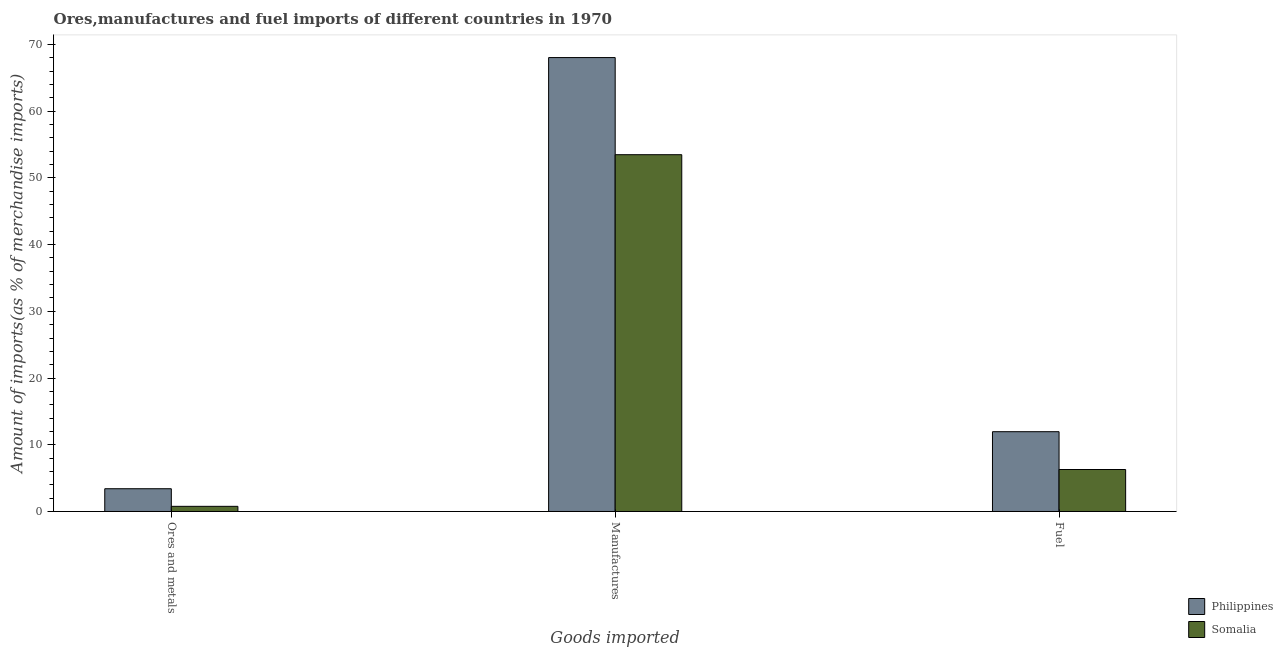How many bars are there on the 3rd tick from the left?
Offer a very short reply. 2. What is the label of the 1st group of bars from the left?
Your answer should be compact. Ores and metals. What is the percentage of manufactures imports in Philippines?
Make the answer very short. 68.03. Across all countries, what is the maximum percentage of manufactures imports?
Offer a very short reply. 68.03. Across all countries, what is the minimum percentage of fuel imports?
Your answer should be very brief. 6.29. In which country was the percentage of fuel imports minimum?
Offer a terse response. Somalia. What is the total percentage of manufactures imports in the graph?
Offer a terse response. 121.51. What is the difference between the percentage of manufactures imports in Somalia and that in Philippines?
Your answer should be very brief. -14.56. What is the difference between the percentage of fuel imports in Somalia and the percentage of manufactures imports in Philippines?
Make the answer very short. -61.74. What is the average percentage of fuel imports per country?
Make the answer very short. 9.12. What is the difference between the percentage of manufactures imports and percentage of ores and metals imports in Somalia?
Keep it short and to the point. 52.7. What is the ratio of the percentage of manufactures imports in Philippines to that in Somalia?
Ensure brevity in your answer.  1.27. Is the difference between the percentage of ores and metals imports in Somalia and Philippines greater than the difference between the percentage of fuel imports in Somalia and Philippines?
Keep it short and to the point. Yes. What is the difference between the highest and the second highest percentage of ores and metals imports?
Provide a short and direct response. 2.64. What is the difference between the highest and the lowest percentage of manufactures imports?
Offer a terse response. 14.56. In how many countries, is the percentage of ores and metals imports greater than the average percentage of ores and metals imports taken over all countries?
Keep it short and to the point. 1. Is the sum of the percentage of manufactures imports in Philippines and Somalia greater than the maximum percentage of ores and metals imports across all countries?
Ensure brevity in your answer.  Yes. What does the 1st bar from the right in Manufactures represents?
Your answer should be compact. Somalia. How many countries are there in the graph?
Ensure brevity in your answer.  2. Does the graph contain any zero values?
Offer a very short reply. No. Does the graph contain grids?
Make the answer very short. No. Where does the legend appear in the graph?
Make the answer very short. Bottom right. How are the legend labels stacked?
Make the answer very short. Vertical. What is the title of the graph?
Ensure brevity in your answer.  Ores,manufactures and fuel imports of different countries in 1970. What is the label or title of the X-axis?
Your answer should be compact. Goods imported. What is the label or title of the Y-axis?
Offer a very short reply. Amount of imports(as % of merchandise imports). What is the Amount of imports(as % of merchandise imports) in Philippines in Ores and metals?
Your answer should be very brief. 3.41. What is the Amount of imports(as % of merchandise imports) in Somalia in Ores and metals?
Your response must be concise. 0.77. What is the Amount of imports(as % of merchandise imports) in Philippines in Manufactures?
Make the answer very short. 68.03. What is the Amount of imports(as % of merchandise imports) in Somalia in Manufactures?
Your answer should be very brief. 53.47. What is the Amount of imports(as % of merchandise imports) of Philippines in Fuel?
Your answer should be compact. 11.96. What is the Amount of imports(as % of merchandise imports) of Somalia in Fuel?
Offer a terse response. 6.29. Across all Goods imported, what is the maximum Amount of imports(as % of merchandise imports) of Philippines?
Give a very brief answer. 68.03. Across all Goods imported, what is the maximum Amount of imports(as % of merchandise imports) of Somalia?
Your response must be concise. 53.47. Across all Goods imported, what is the minimum Amount of imports(as % of merchandise imports) in Philippines?
Your answer should be very brief. 3.41. Across all Goods imported, what is the minimum Amount of imports(as % of merchandise imports) in Somalia?
Keep it short and to the point. 0.77. What is the total Amount of imports(as % of merchandise imports) of Philippines in the graph?
Your response must be concise. 83.4. What is the total Amount of imports(as % of merchandise imports) in Somalia in the graph?
Your response must be concise. 60.54. What is the difference between the Amount of imports(as % of merchandise imports) in Philippines in Ores and metals and that in Manufactures?
Make the answer very short. -64.62. What is the difference between the Amount of imports(as % of merchandise imports) in Somalia in Ores and metals and that in Manufactures?
Your response must be concise. -52.7. What is the difference between the Amount of imports(as % of merchandise imports) in Philippines in Ores and metals and that in Fuel?
Your answer should be very brief. -8.55. What is the difference between the Amount of imports(as % of merchandise imports) in Somalia in Ores and metals and that in Fuel?
Your answer should be very brief. -5.52. What is the difference between the Amount of imports(as % of merchandise imports) of Philippines in Manufactures and that in Fuel?
Your answer should be very brief. 56.07. What is the difference between the Amount of imports(as % of merchandise imports) of Somalia in Manufactures and that in Fuel?
Give a very brief answer. 47.18. What is the difference between the Amount of imports(as % of merchandise imports) of Philippines in Ores and metals and the Amount of imports(as % of merchandise imports) of Somalia in Manufactures?
Your response must be concise. -50.06. What is the difference between the Amount of imports(as % of merchandise imports) of Philippines in Ores and metals and the Amount of imports(as % of merchandise imports) of Somalia in Fuel?
Your answer should be compact. -2.88. What is the difference between the Amount of imports(as % of merchandise imports) of Philippines in Manufactures and the Amount of imports(as % of merchandise imports) of Somalia in Fuel?
Offer a very short reply. 61.74. What is the average Amount of imports(as % of merchandise imports) in Philippines per Goods imported?
Offer a very short reply. 27.8. What is the average Amount of imports(as % of merchandise imports) in Somalia per Goods imported?
Provide a short and direct response. 20.18. What is the difference between the Amount of imports(as % of merchandise imports) of Philippines and Amount of imports(as % of merchandise imports) of Somalia in Ores and metals?
Offer a terse response. 2.64. What is the difference between the Amount of imports(as % of merchandise imports) in Philippines and Amount of imports(as % of merchandise imports) in Somalia in Manufactures?
Your response must be concise. 14.56. What is the difference between the Amount of imports(as % of merchandise imports) in Philippines and Amount of imports(as % of merchandise imports) in Somalia in Fuel?
Offer a terse response. 5.67. What is the ratio of the Amount of imports(as % of merchandise imports) of Philippines in Ores and metals to that in Manufactures?
Ensure brevity in your answer.  0.05. What is the ratio of the Amount of imports(as % of merchandise imports) in Somalia in Ores and metals to that in Manufactures?
Provide a short and direct response. 0.01. What is the ratio of the Amount of imports(as % of merchandise imports) in Philippines in Ores and metals to that in Fuel?
Keep it short and to the point. 0.29. What is the ratio of the Amount of imports(as % of merchandise imports) of Somalia in Ores and metals to that in Fuel?
Ensure brevity in your answer.  0.12. What is the ratio of the Amount of imports(as % of merchandise imports) of Philippines in Manufactures to that in Fuel?
Your response must be concise. 5.69. What is the ratio of the Amount of imports(as % of merchandise imports) in Somalia in Manufactures to that in Fuel?
Ensure brevity in your answer.  8.5. What is the difference between the highest and the second highest Amount of imports(as % of merchandise imports) in Philippines?
Offer a terse response. 56.07. What is the difference between the highest and the second highest Amount of imports(as % of merchandise imports) in Somalia?
Your answer should be compact. 47.18. What is the difference between the highest and the lowest Amount of imports(as % of merchandise imports) in Philippines?
Give a very brief answer. 64.62. What is the difference between the highest and the lowest Amount of imports(as % of merchandise imports) in Somalia?
Ensure brevity in your answer.  52.7. 